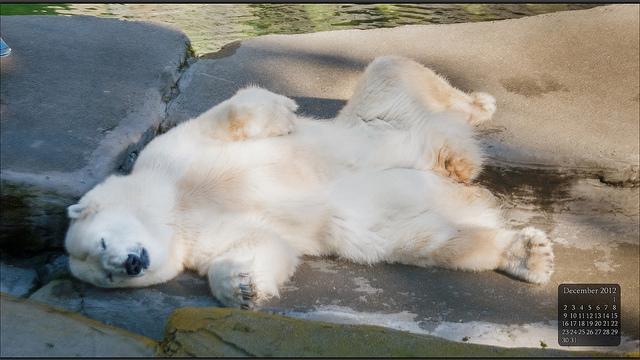How many people are walking on the sidewalk?
Give a very brief answer. 0. 